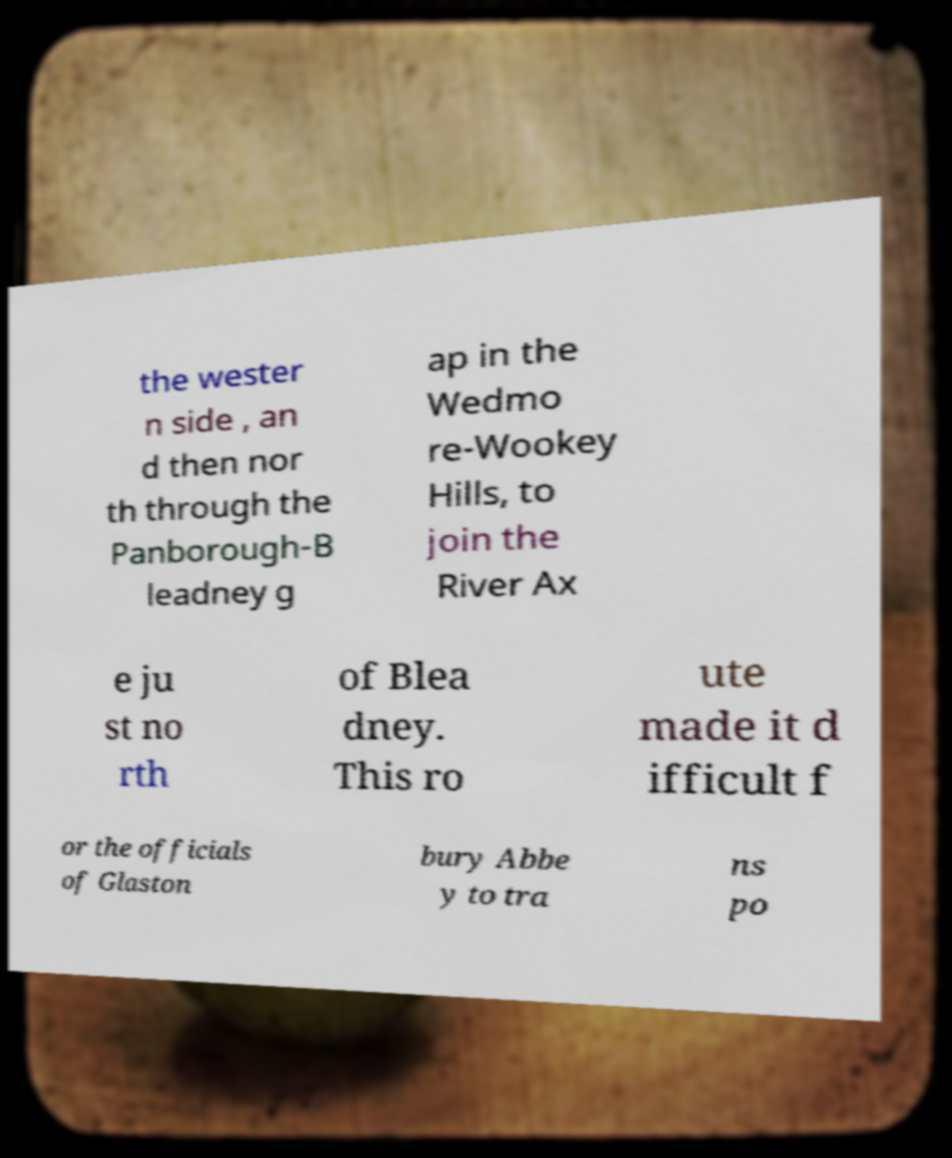Could you extract and type out the text from this image? the wester n side , an d then nor th through the Panborough-B leadney g ap in the Wedmo re-Wookey Hills, to join the River Ax e ju st no rth of Blea dney. This ro ute made it d ifficult f or the officials of Glaston bury Abbe y to tra ns po 